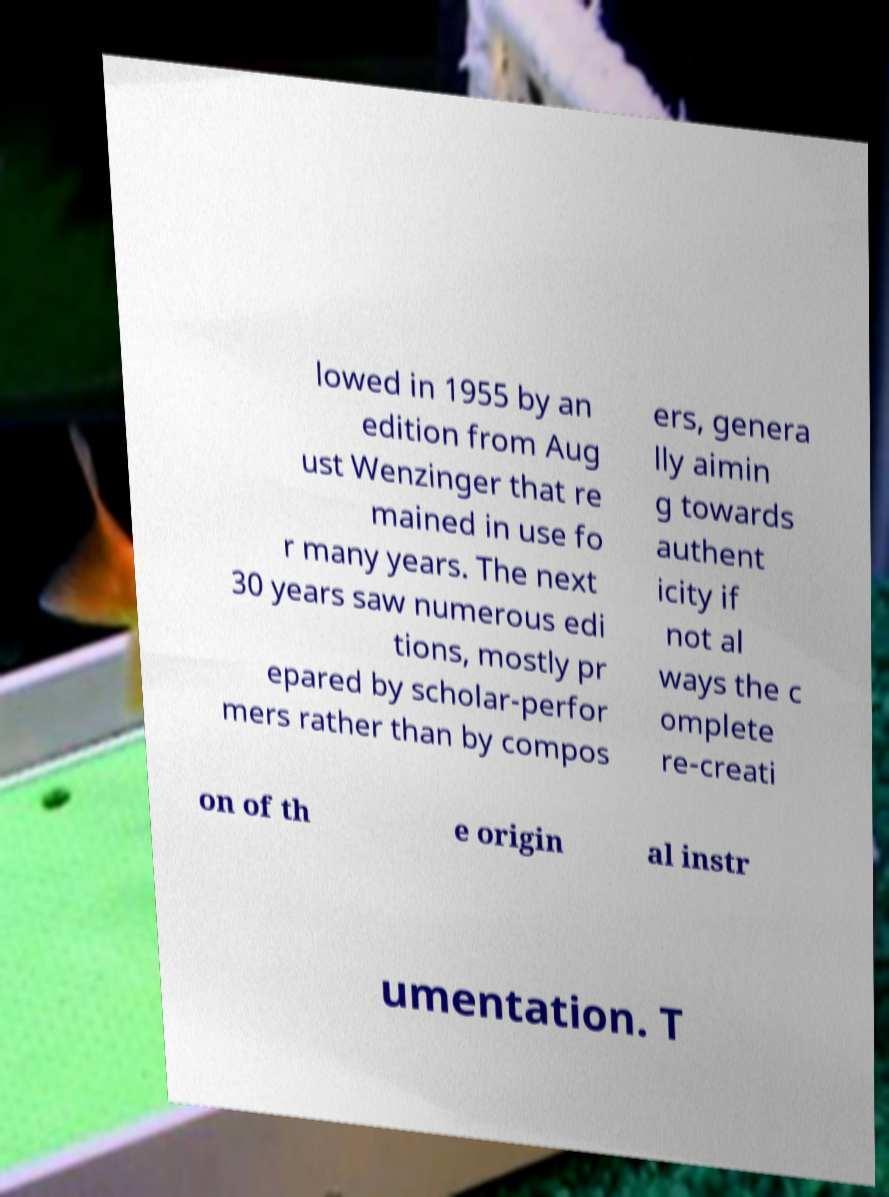Please read and relay the text visible in this image. What does it say? lowed in 1955 by an edition from Aug ust Wenzinger that re mained in use fo r many years. The next 30 years saw numerous edi tions, mostly pr epared by scholar-perfor mers rather than by compos ers, genera lly aimin g towards authent icity if not al ways the c omplete re-creati on of th e origin al instr umentation. T 